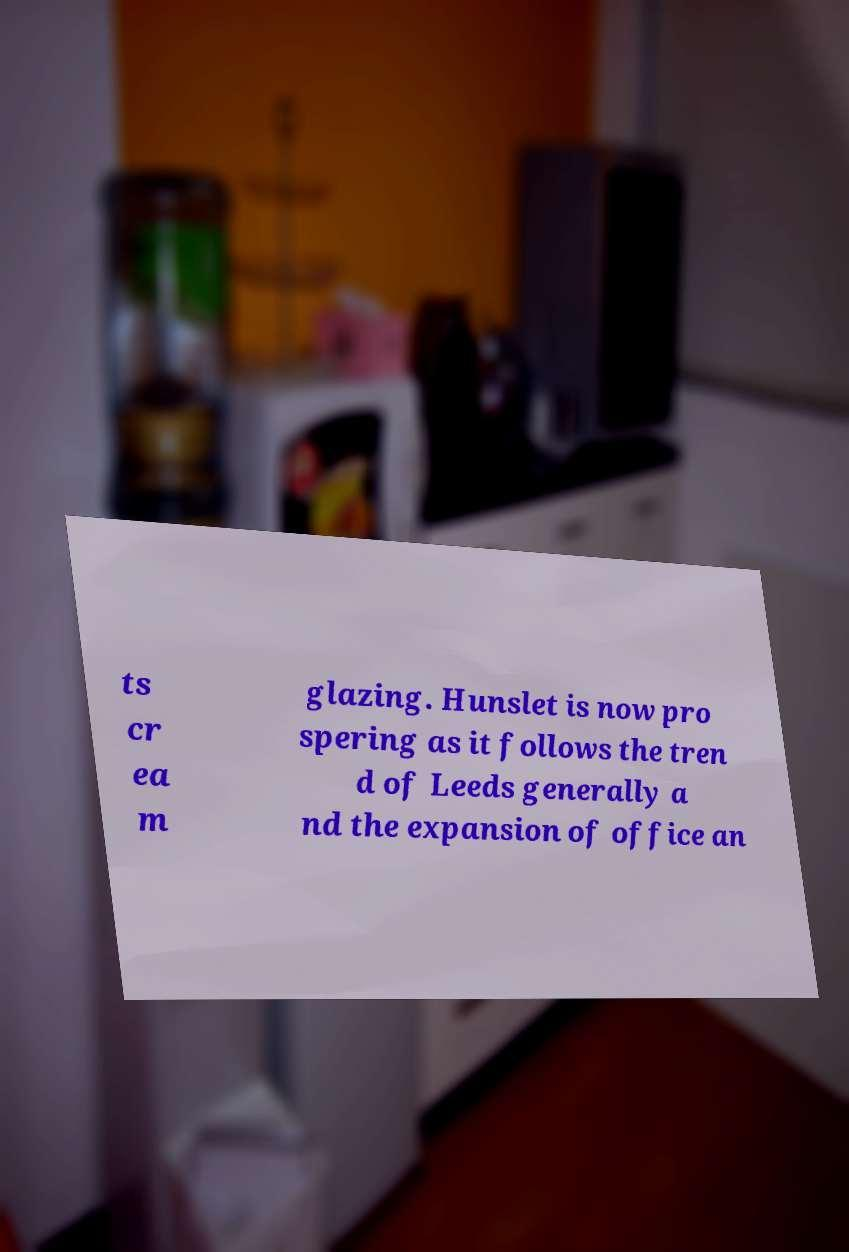I need the written content from this picture converted into text. Can you do that? ts cr ea m glazing. Hunslet is now pro spering as it follows the tren d of Leeds generally a nd the expansion of office an 